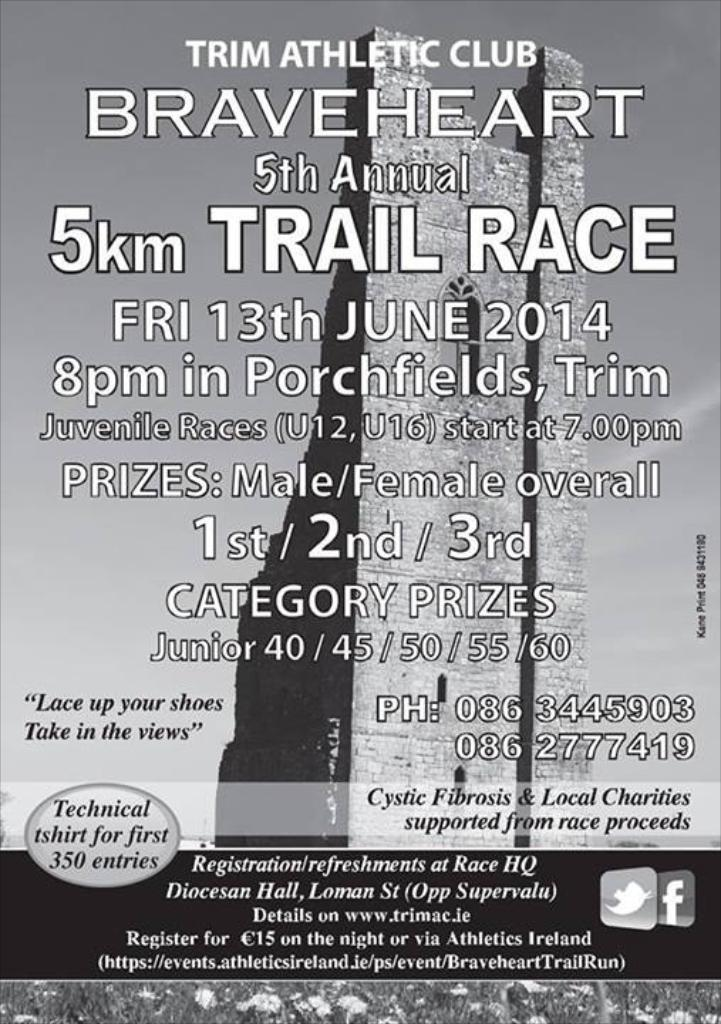<image>
Offer a succinct explanation of the picture presented. Poster for a race that takes place on June 13th. 